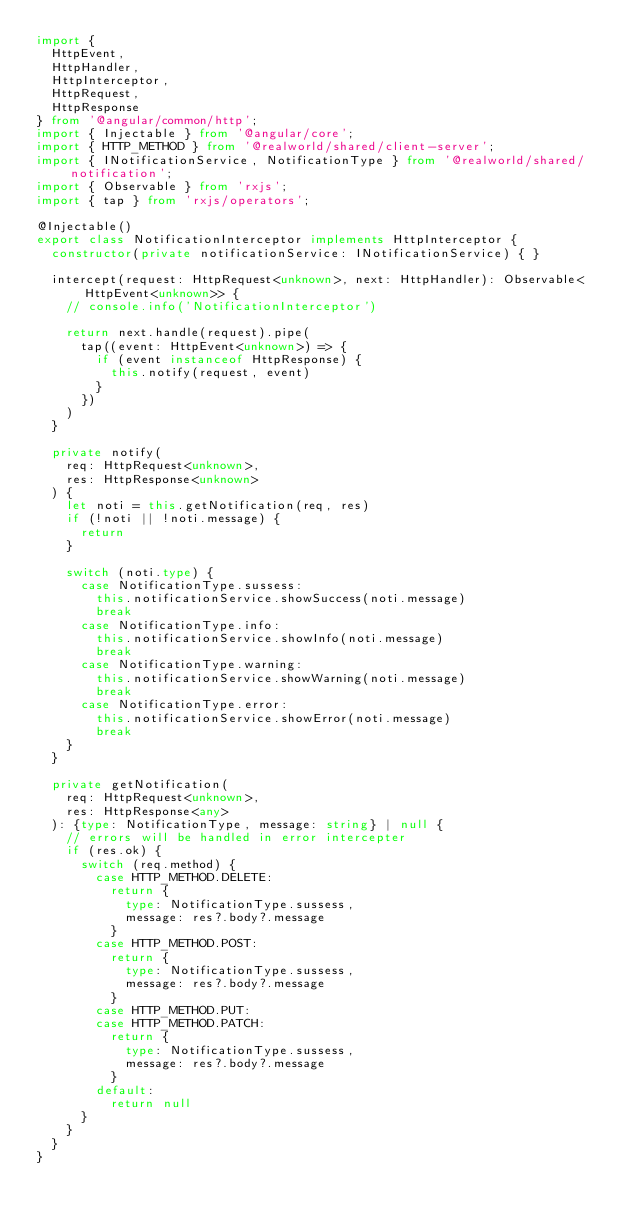Convert code to text. <code><loc_0><loc_0><loc_500><loc_500><_TypeScript_>import {
  HttpEvent,
  HttpHandler,
  HttpInterceptor,
  HttpRequest,
  HttpResponse
} from '@angular/common/http';
import { Injectable } from '@angular/core';
import { HTTP_METHOD } from '@realworld/shared/client-server';
import { INotificationService, NotificationType } from '@realworld/shared/notification';
import { Observable } from 'rxjs';
import { tap } from 'rxjs/operators';

@Injectable()
export class NotificationInterceptor implements HttpInterceptor {
  constructor(private notificationService: INotificationService) { }

  intercept(request: HttpRequest<unknown>, next: HttpHandler): Observable<HttpEvent<unknown>> {
    // console.info('NotificationInterceptor')
    
    return next.handle(request).pipe(
      tap((event: HttpEvent<unknown>) => {
        if (event instanceof HttpResponse) {
          this.notify(request, event)
        }
      })
    )
  }

  private notify(
    req: HttpRequest<unknown>, 
    res: HttpResponse<unknown>
  ) {
    let noti = this.getNotification(req, res)
    if (!noti || !noti.message) {
      return 
    }

    switch (noti.type) {
      case NotificationType.sussess:
        this.notificationService.showSuccess(noti.message)
        break
      case NotificationType.info:
        this.notificationService.showInfo(noti.message)
        break
      case NotificationType.warning:
        this.notificationService.showWarning(noti.message)
        break
      case NotificationType.error:
        this.notificationService.showError(noti.message)
        break
    }
  }

  private getNotification(
    req: HttpRequest<unknown>, 
    res: HttpResponse<any>
  ): {type: NotificationType, message: string} | null {
    // errors will be handled in error intercepter
    if (res.ok) { 
      switch (req.method) {
        case HTTP_METHOD.DELETE:
          return {
            type: NotificationType.sussess,
            message: res?.body?.message 
          }
        case HTTP_METHOD.POST:
          return {
            type: NotificationType.sussess,
            message: res?.body?.message  
          }
        case HTTP_METHOD.PUT:
        case HTTP_METHOD.PATCH:
          return {
            type: NotificationType.sussess,
            message: res?.body?.message 
          }
        default: 
          return null
      }
    }
  }
}
</code> 